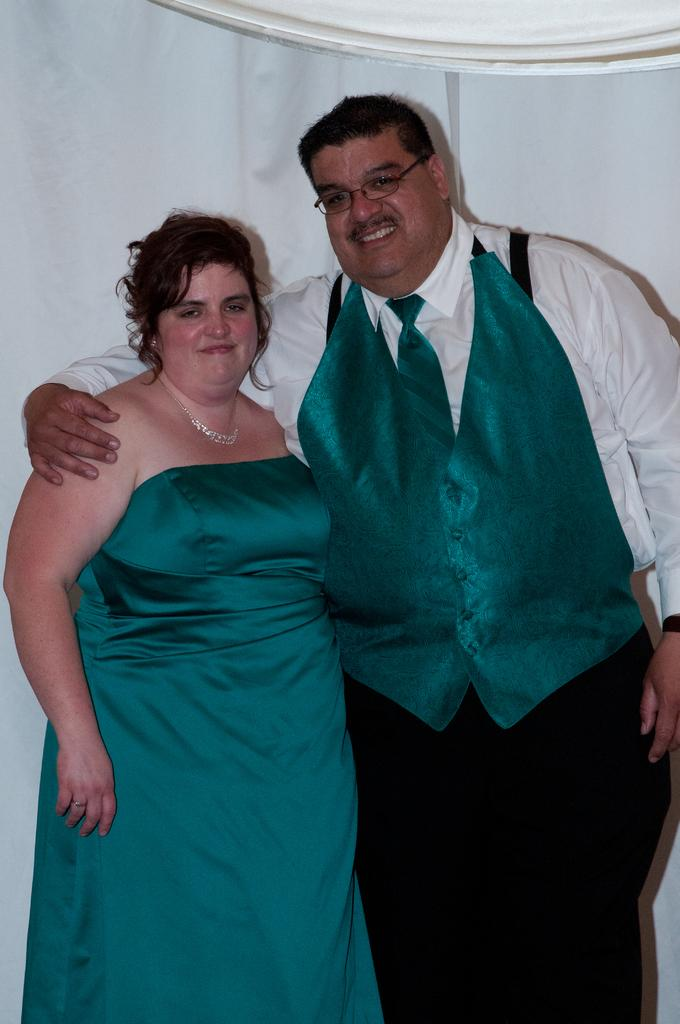What is the gender of the person in the image? There is a man and a woman in the image. What are the positions of the man and woman in the image? Both the man and the woman are standing. What expressions do the man and woman have in the image? Both the man and the woman are smiling. What type of insect can be seen crawling on the man's shoulder in the image? There is no insect present on the man's shoulder in the image. Is the scene in the image taking place in a hot environment? The provided facts do not mention the temperature or environment, so it cannot be determined from the image. 